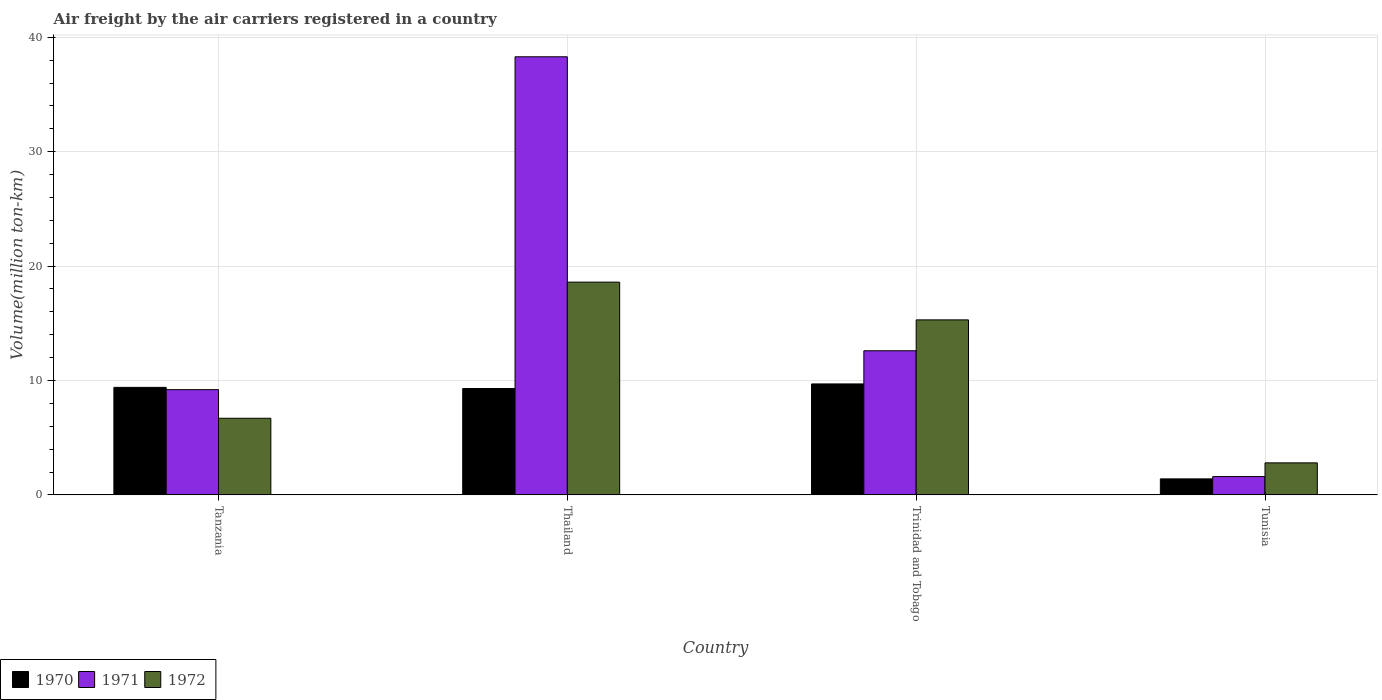How many different coloured bars are there?
Ensure brevity in your answer.  3. Are the number of bars per tick equal to the number of legend labels?
Ensure brevity in your answer.  Yes. How many bars are there on the 2nd tick from the left?
Offer a very short reply. 3. What is the label of the 2nd group of bars from the left?
Make the answer very short. Thailand. In how many cases, is the number of bars for a given country not equal to the number of legend labels?
Ensure brevity in your answer.  0. What is the volume of the air carriers in 1970 in Tanzania?
Offer a very short reply. 9.4. Across all countries, what is the maximum volume of the air carriers in 1971?
Your answer should be compact. 38.3. Across all countries, what is the minimum volume of the air carriers in 1972?
Your answer should be very brief. 2.8. In which country was the volume of the air carriers in 1971 maximum?
Ensure brevity in your answer.  Thailand. In which country was the volume of the air carriers in 1972 minimum?
Provide a short and direct response. Tunisia. What is the total volume of the air carriers in 1971 in the graph?
Ensure brevity in your answer.  61.7. What is the difference between the volume of the air carriers in 1970 in Thailand and that in Tunisia?
Your answer should be compact. 7.9. What is the difference between the volume of the air carriers in 1971 in Trinidad and Tobago and the volume of the air carriers in 1970 in Tunisia?
Give a very brief answer. 11.2. What is the average volume of the air carriers in 1972 per country?
Your response must be concise. 10.85. What is the difference between the volume of the air carriers of/in 1971 and volume of the air carriers of/in 1970 in Trinidad and Tobago?
Make the answer very short. 2.9. What is the ratio of the volume of the air carriers in 1970 in Trinidad and Tobago to that in Tunisia?
Offer a very short reply. 6.93. Is the volume of the air carriers in 1972 in Thailand less than that in Trinidad and Tobago?
Offer a very short reply. No. What is the difference between the highest and the second highest volume of the air carriers in 1970?
Your answer should be very brief. 0.3. What is the difference between the highest and the lowest volume of the air carriers in 1971?
Keep it short and to the point. 36.7. What does the 1st bar from the right in Tanzania represents?
Make the answer very short. 1972. Is it the case that in every country, the sum of the volume of the air carriers in 1970 and volume of the air carriers in 1972 is greater than the volume of the air carriers in 1971?
Your response must be concise. No. How many countries are there in the graph?
Provide a short and direct response. 4. Does the graph contain any zero values?
Your answer should be compact. No. Does the graph contain grids?
Your response must be concise. Yes. Where does the legend appear in the graph?
Offer a very short reply. Bottom left. How many legend labels are there?
Give a very brief answer. 3. How are the legend labels stacked?
Make the answer very short. Horizontal. What is the title of the graph?
Your answer should be very brief. Air freight by the air carriers registered in a country. Does "1995" appear as one of the legend labels in the graph?
Provide a succinct answer. No. What is the label or title of the Y-axis?
Your answer should be very brief. Volume(million ton-km). What is the Volume(million ton-km) in 1970 in Tanzania?
Provide a succinct answer. 9.4. What is the Volume(million ton-km) in 1971 in Tanzania?
Ensure brevity in your answer.  9.2. What is the Volume(million ton-km) in 1972 in Tanzania?
Ensure brevity in your answer.  6.7. What is the Volume(million ton-km) of 1970 in Thailand?
Your response must be concise. 9.3. What is the Volume(million ton-km) in 1971 in Thailand?
Give a very brief answer. 38.3. What is the Volume(million ton-km) in 1972 in Thailand?
Keep it short and to the point. 18.6. What is the Volume(million ton-km) of 1970 in Trinidad and Tobago?
Your response must be concise. 9.7. What is the Volume(million ton-km) of 1971 in Trinidad and Tobago?
Your answer should be compact. 12.6. What is the Volume(million ton-km) of 1972 in Trinidad and Tobago?
Keep it short and to the point. 15.3. What is the Volume(million ton-km) of 1970 in Tunisia?
Offer a very short reply. 1.4. What is the Volume(million ton-km) of 1971 in Tunisia?
Provide a succinct answer. 1.6. What is the Volume(million ton-km) of 1972 in Tunisia?
Your answer should be very brief. 2.8. Across all countries, what is the maximum Volume(million ton-km) in 1970?
Your answer should be very brief. 9.7. Across all countries, what is the maximum Volume(million ton-km) in 1971?
Ensure brevity in your answer.  38.3. Across all countries, what is the maximum Volume(million ton-km) in 1972?
Offer a terse response. 18.6. Across all countries, what is the minimum Volume(million ton-km) of 1970?
Ensure brevity in your answer.  1.4. Across all countries, what is the minimum Volume(million ton-km) in 1971?
Give a very brief answer. 1.6. Across all countries, what is the minimum Volume(million ton-km) of 1972?
Your response must be concise. 2.8. What is the total Volume(million ton-km) of 1970 in the graph?
Your response must be concise. 29.8. What is the total Volume(million ton-km) of 1971 in the graph?
Your answer should be compact. 61.7. What is the total Volume(million ton-km) in 1972 in the graph?
Provide a short and direct response. 43.4. What is the difference between the Volume(million ton-km) in 1971 in Tanzania and that in Thailand?
Your answer should be compact. -29.1. What is the difference between the Volume(million ton-km) in 1972 in Tanzania and that in Thailand?
Ensure brevity in your answer.  -11.9. What is the difference between the Volume(million ton-km) in 1971 in Tanzania and that in Trinidad and Tobago?
Your response must be concise. -3.4. What is the difference between the Volume(million ton-km) of 1971 in Thailand and that in Trinidad and Tobago?
Make the answer very short. 25.7. What is the difference between the Volume(million ton-km) in 1972 in Thailand and that in Trinidad and Tobago?
Give a very brief answer. 3.3. What is the difference between the Volume(million ton-km) in 1970 in Thailand and that in Tunisia?
Offer a terse response. 7.9. What is the difference between the Volume(million ton-km) in 1971 in Thailand and that in Tunisia?
Provide a succinct answer. 36.7. What is the difference between the Volume(million ton-km) of 1972 in Thailand and that in Tunisia?
Your response must be concise. 15.8. What is the difference between the Volume(million ton-km) in 1970 in Trinidad and Tobago and that in Tunisia?
Your answer should be compact. 8.3. What is the difference between the Volume(million ton-km) of 1970 in Tanzania and the Volume(million ton-km) of 1971 in Thailand?
Make the answer very short. -28.9. What is the difference between the Volume(million ton-km) of 1970 in Tanzania and the Volume(million ton-km) of 1972 in Thailand?
Provide a short and direct response. -9.2. What is the difference between the Volume(million ton-km) of 1971 in Tanzania and the Volume(million ton-km) of 1972 in Tunisia?
Give a very brief answer. 6.4. What is the difference between the Volume(million ton-km) of 1970 in Thailand and the Volume(million ton-km) of 1971 in Trinidad and Tobago?
Your answer should be compact. -3.3. What is the difference between the Volume(million ton-km) of 1970 in Thailand and the Volume(million ton-km) of 1972 in Trinidad and Tobago?
Make the answer very short. -6. What is the difference between the Volume(million ton-km) in 1971 in Thailand and the Volume(million ton-km) in 1972 in Trinidad and Tobago?
Your answer should be very brief. 23. What is the difference between the Volume(million ton-km) in 1971 in Thailand and the Volume(million ton-km) in 1972 in Tunisia?
Your response must be concise. 35.5. What is the difference between the Volume(million ton-km) of 1970 in Trinidad and Tobago and the Volume(million ton-km) of 1971 in Tunisia?
Ensure brevity in your answer.  8.1. What is the average Volume(million ton-km) in 1970 per country?
Your answer should be very brief. 7.45. What is the average Volume(million ton-km) in 1971 per country?
Your answer should be compact. 15.43. What is the average Volume(million ton-km) of 1972 per country?
Provide a succinct answer. 10.85. What is the difference between the Volume(million ton-km) in 1970 and Volume(million ton-km) in 1971 in Tanzania?
Provide a succinct answer. 0.2. What is the difference between the Volume(million ton-km) of 1970 and Volume(million ton-km) of 1971 in Thailand?
Give a very brief answer. -29. What is the difference between the Volume(million ton-km) in 1971 and Volume(million ton-km) in 1972 in Trinidad and Tobago?
Your answer should be very brief. -2.7. What is the difference between the Volume(million ton-km) in 1970 and Volume(million ton-km) in 1971 in Tunisia?
Offer a terse response. -0.2. What is the difference between the Volume(million ton-km) of 1970 and Volume(million ton-km) of 1972 in Tunisia?
Offer a terse response. -1.4. What is the difference between the Volume(million ton-km) in 1971 and Volume(million ton-km) in 1972 in Tunisia?
Your response must be concise. -1.2. What is the ratio of the Volume(million ton-km) of 1970 in Tanzania to that in Thailand?
Keep it short and to the point. 1.01. What is the ratio of the Volume(million ton-km) of 1971 in Tanzania to that in Thailand?
Provide a short and direct response. 0.24. What is the ratio of the Volume(million ton-km) in 1972 in Tanzania to that in Thailand?
Give a very brief answer. 0.36. What is the ratio of the Volume(million ton-km) in 1970 in Tanzania to that in Trinidad and Tobago?
Provide a succinct answer. 0.97. What is the ratio of the Volume(million ton-km) of 1971 in Tanzania to that in Trinidad and Tobago?
Keep it short and to the point. 0.73. What is the ratio of the Volume(million ton-km) of 1972 in Tanzania to that in Trinidad and Tobago?
Provide a short and direct response. 0.44. What is the ratio of the Volume(million ton-km) in 1970 in Tanzania to that in Tunisia?
Ensure brevity in your answer.  6.71. What is the ratio of the Volume(million ton-km) in 1971 in Tanzania to that in Tunisia?
Provide a short and direct response. 5.75. What is the ratio of the Volume(million ton-km) in 1972 in Tanzania to that in Tunisia?
Keep it short and to the point. 2.39. What is the ratio of the Volume(million ton-km) of 1970 in Thailand to that in Trinidad and Tobago?
Offer a terse response. 0.96. What is the ratio of the Volume(million ton-km) of 1971 in Thailand to that in Trinidad and Tobago?
Your answer should be compact. 3.04. What is the ratio of the Volume(million ton-km) of 1972 in Thailand to that in Trinidad and Tobago?
Make the answer very short. 1.22. What is the ratio of the Volume(million ton-km) of 1970 in Thailand to that in Tunisia?
Your answer should be very brief. 6.64. What is the ratio of the Volume(million ton-km) in 1971 in Thailand to that in Tunisia?
Offer a very short reply. 23.94. What is the ratio of the Volume(million ton-km) in 1972 in Thailand to that in Tunisia?
Make the answer very short. 6.64. What is the ratio of the Volume(million ton-km) in 1970 in Trinidad and Tobago to that in Tunisia?
Ensure brevity in your answer.  6.93. What is the ratio of the Volume(million ton-km) in 1971 in Trinidad and Tobago to that in Tunisia?
Offer a terse response. 7.88. What is the ratio of the Volume(million ton-km) of 1972 in Trinidad and Tobago to that in Tunisia?
Provide a short and direct response. 5.46. What is the difference between the highest and the second highest Volume(million ton-km) in 1970?
Make the answer very short. 0.3. What is the difference between the highest and the second highest Volume(million ton-km) of 1971?
Your answer should be compact. 25.7. What is the difference between the highest and the second highest Volume(million ton-km) of 1972?
Make the answer very short. 3.3. What is the difference between the highest and the lowest Volume(million ton-km) in 1970?
Give a very brief answer. 8.3. What is the difference between the highest and the lowest Volume(million ton-km) of 1971?
Provide a succinct answer. 36.7. 